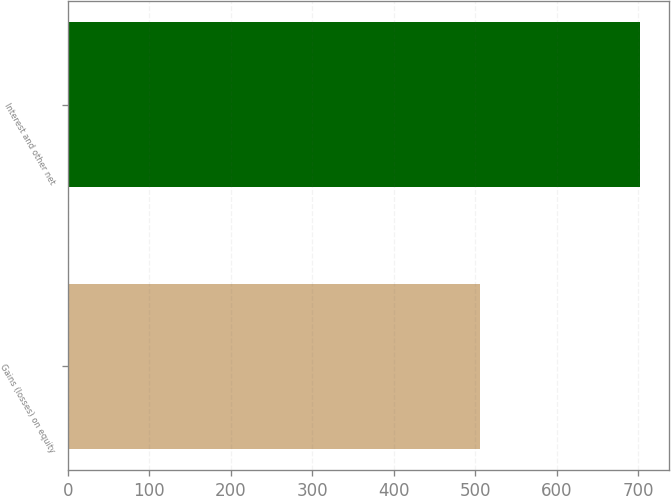<chart> <loc_0><loc_0><loc_500><loc_500><bar_chart><fcel>Gains (losses) on equity<fcel>Interest and other net<nl><fcel>506<fcel>703<nl></chart> 